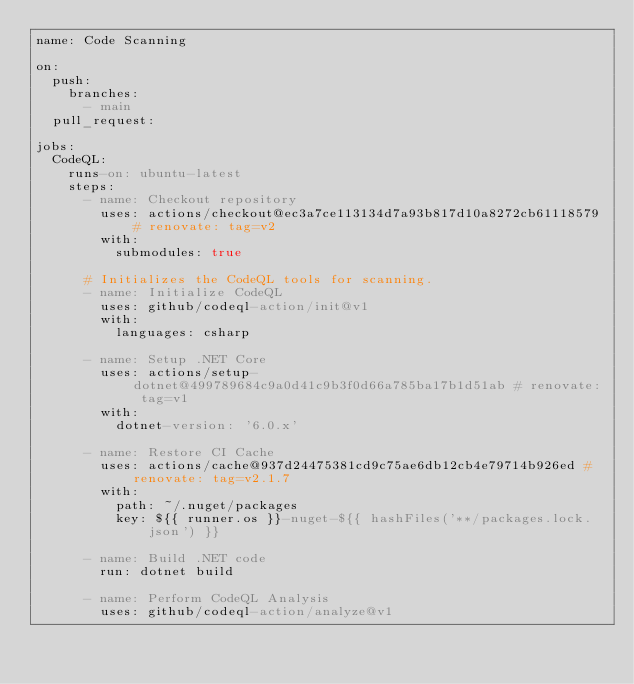<code> <loc_0><loc_0><loc_500><loc_500><_YAML_>name: Code Scanning

on:
  push:
    branches:
      - main
  pull_request:

jobs:
  CodeQL:
    runs-on: ubuntu-latest
    steps:
      - name: Checkout repository
        uses: actions/checkout@ec3a7ce113134d7a93b817d10a8272cb61118579 # renovate: tag=v2
        with:
          submodules: true

      # Initializes the CodeQL tools for scanning.
      - name: Initialize CodeQL
        uses: github/codeql-action/init@v1
        with:
          languages: csharp

      - name: Setup .NET Core
        uses: actions/setup-dotnet@499789684c9a0d41c9b3f0d66a785ba17b1d51ab # renovate: tag=v1
        with:
          dotnet-version: '6.0.x'

      - name: Restore CI Cache
        uses: actions/cache@937d24475381cd9c75ae6db12cb4e79714b926ed # renovate: tag=v2.1.7
        with:
          path: ~/.nuget/packages
          key: ${{ runner.os }}-nuget-${{ hashFiles('**/packages.lock.json') }}

      - name: Build .NET code
        run: dotnet build

      - name: Perform CodeQL Analysis
        uses: github/codeql-action/analyze@v1
</code> 